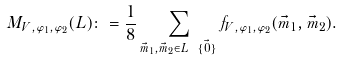<formula> <loc_0><loc_0><loc_500><loc_500>M _ { V , \varphi _ { 1 } , \varphi _ { 2 } } ( L ) \colon = \frac { 1 } { 8 } \sum _ { \vec { m } _ { 1 } , \vec { m } _ { 2 } \in L \ \{ \vec { 0 } \} } f _ { V , \varphi _ { 1 } , \varphi _ { 2 } } ( \vec { m } _ { 1 } , \vec { m } _ { 2 } ) .</formula> 